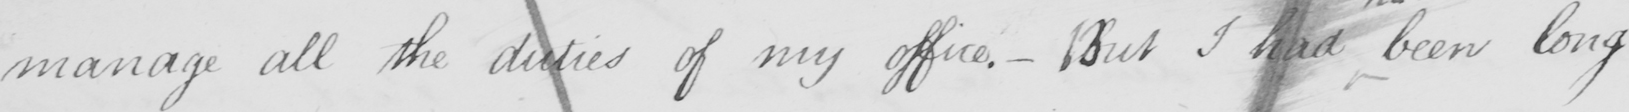Can you read and transcribe this handwriting? manage all the duties of my office - But I had been long 